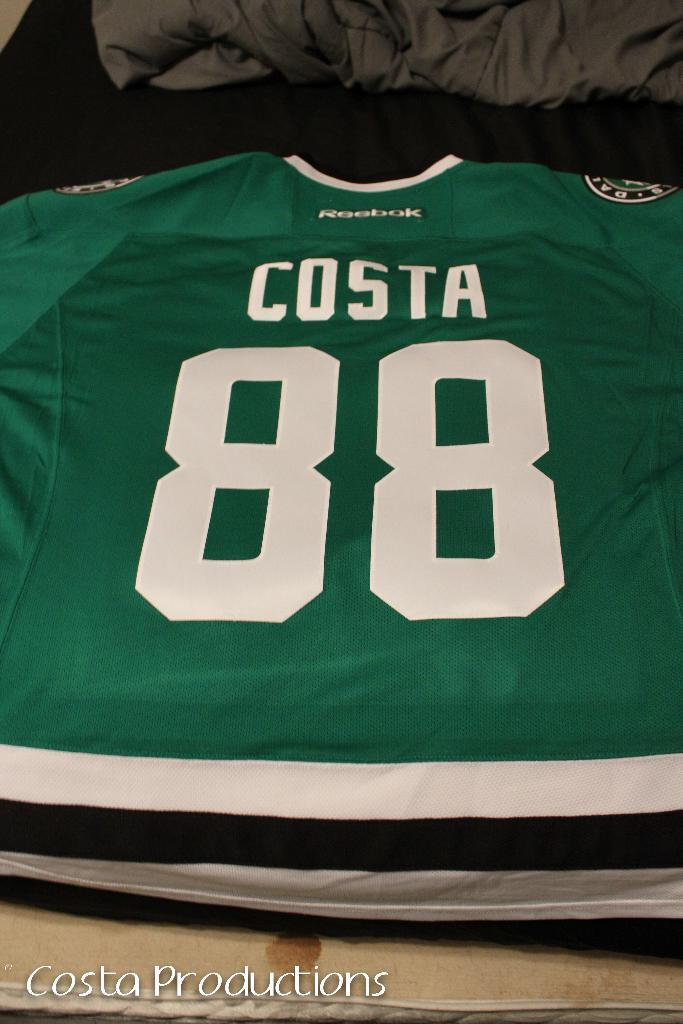Provide a one-sentence caption for the provided image. A green jersey has a number 88 and the name Costa. 